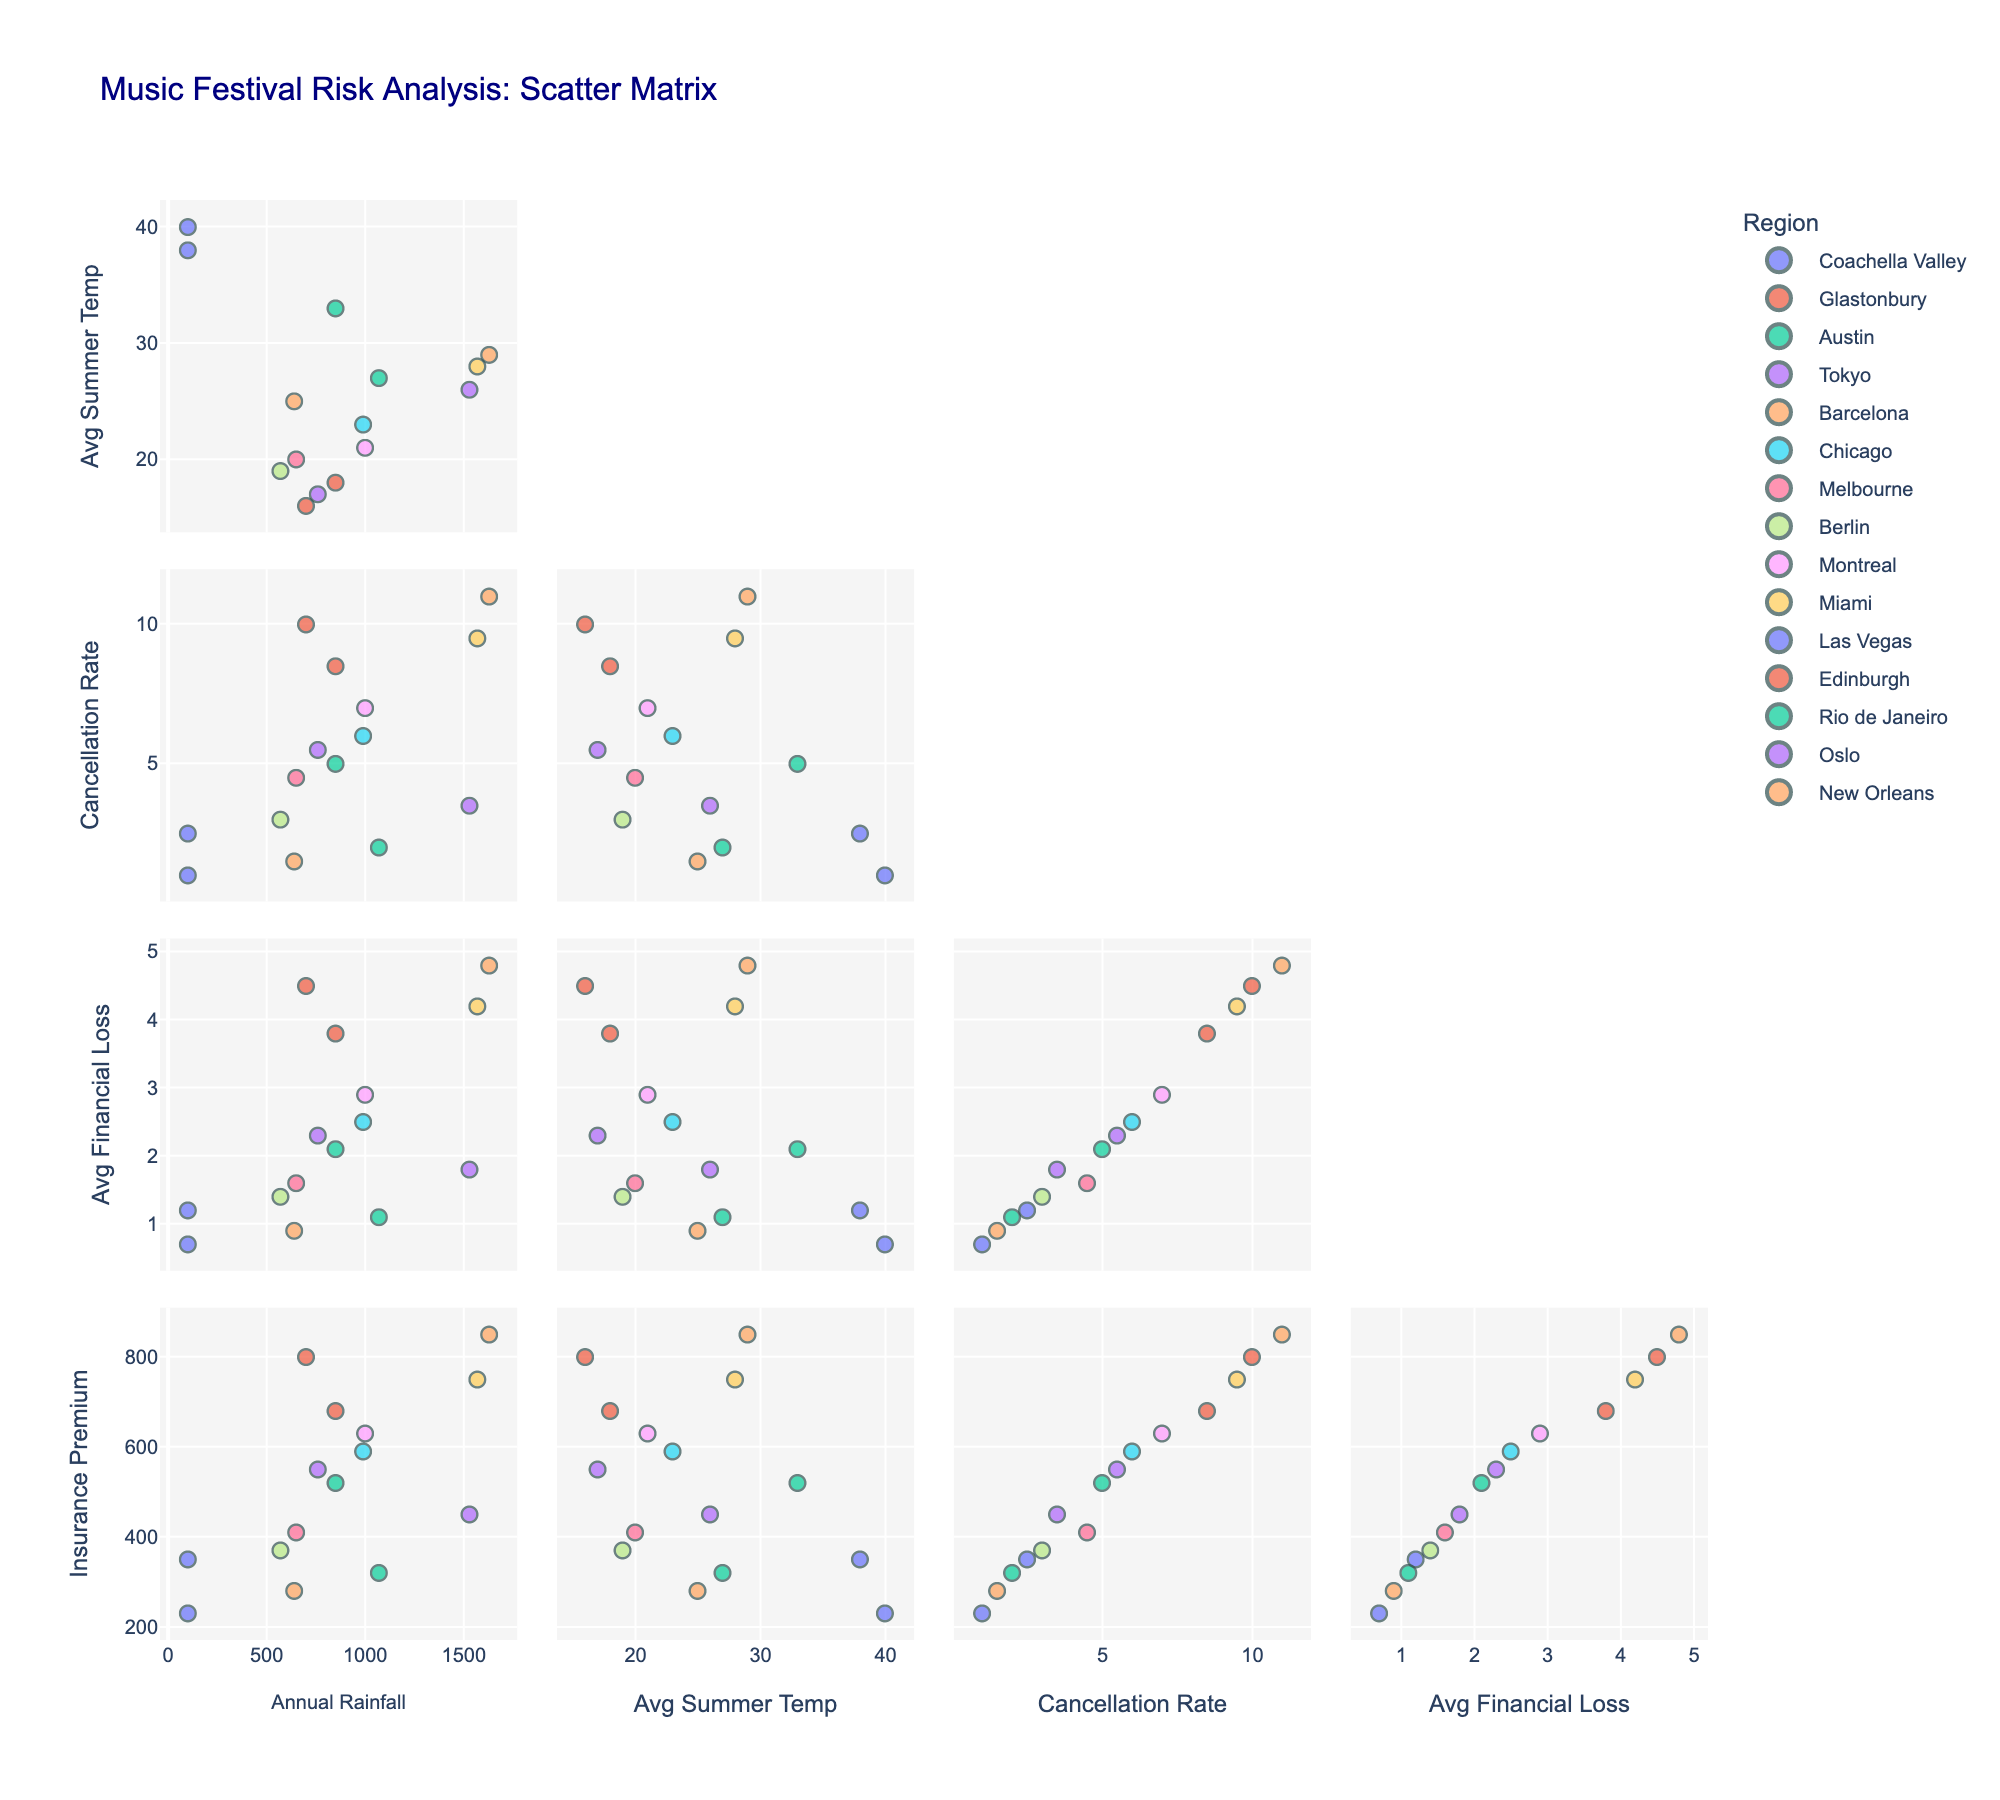What is the title of the figure? The title is usually displayed at the top of the figure and summarizes the content of the visual in a concise manner.
Answer: Music Festival Risk Analysis: Scatter Matrix How many regions are displayed in the scatter matrix? By counting the unique colors or legends associated with each region, we can determine the number of regions.
Answer: 15 Which region has the highest cancellation rate? By examining the 'Cancellation Rate (%)' axis across different regions, we can identify the highest value.
Answer: New Orleans Which region has the highest annual rainfall? By examining the 'Annual Rainfall (mm)' axis across different regions, we can determine the region with the peak value.
Answer: New Orleans What is the relationship between annual rainfall and cancellation rate? By observing the scatter points in the annual rainfall and cancellation rate dimensions, we can analyze any correlation (positive, negative, or none).
Answer: Positive correlation Which region has the lowest insurance premium? By comparing the 'Insurance Premium ($K)' axis across different regions, we can spot the lowest value.
Answer: Las Vegas Which regions experience an average summer temperature above 30°C and have a cancellation rate below 5%? By identifying points in the 'Avg Summer Temp (°C)' dimension above 30 and cross-referencing with points having less than 5% in the 'Cancellation Rate (%)' dimension, we can determine the relevant regions.
Answer: Coachella Valley, Las Vegas, Austin Compare the average financial loss between regions with an average summer temperature above 30°C and those below 30°C. Calculate the average financial loss by grouping regions based on their average summer temperature (above and below 30°C), then compare the two averages. First determine regions in each group: Above 30°C (Coachella Valley, Austin, Las Vegas), Below 30°C (All others). Then, sum and average losses for each group.
Answer: Above 30°C: ($1.2M + $2.1M + $0.7M) / 3 ≈ $1.33M Below 30°C: ($3.8M + $1.8M + $0.9M + $2.5M + $1.6M + $1.4M + $2.9M + $4.2M + $4.5M + $2.3M + $1.1M + $4.8M) / 12 ≈ $2.68M Is there a trend between average financial loss and insurance premium? By observing the scatter points in both 'Avg Financial Loss ($M)' and 'Insurance Premium ($K)' dimensions, we can analyze any correlation (positive, negative, or none).
Answer: Positive correlation Which region has the highest average financial loss despite having a medium annual rainfall? Find the region with medium rainfall (e.g., around 700-1000 mm) and check for the highest average financial loss within that group.
Answer: Montreal 